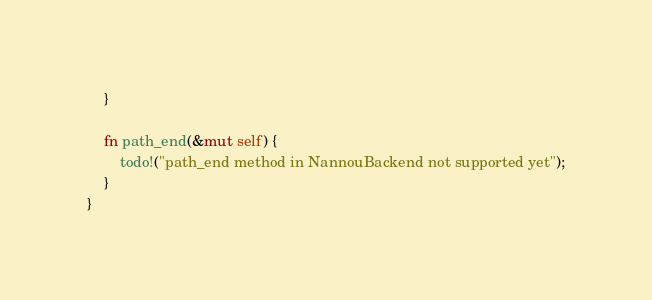<code> <loc_0><loc_0><loc_500><loc_500><_Rust_>    }

    fn path_end(&mut self) {
        todo!("path_end method in NannouBackend not supported yet");
    }
}
</code> 